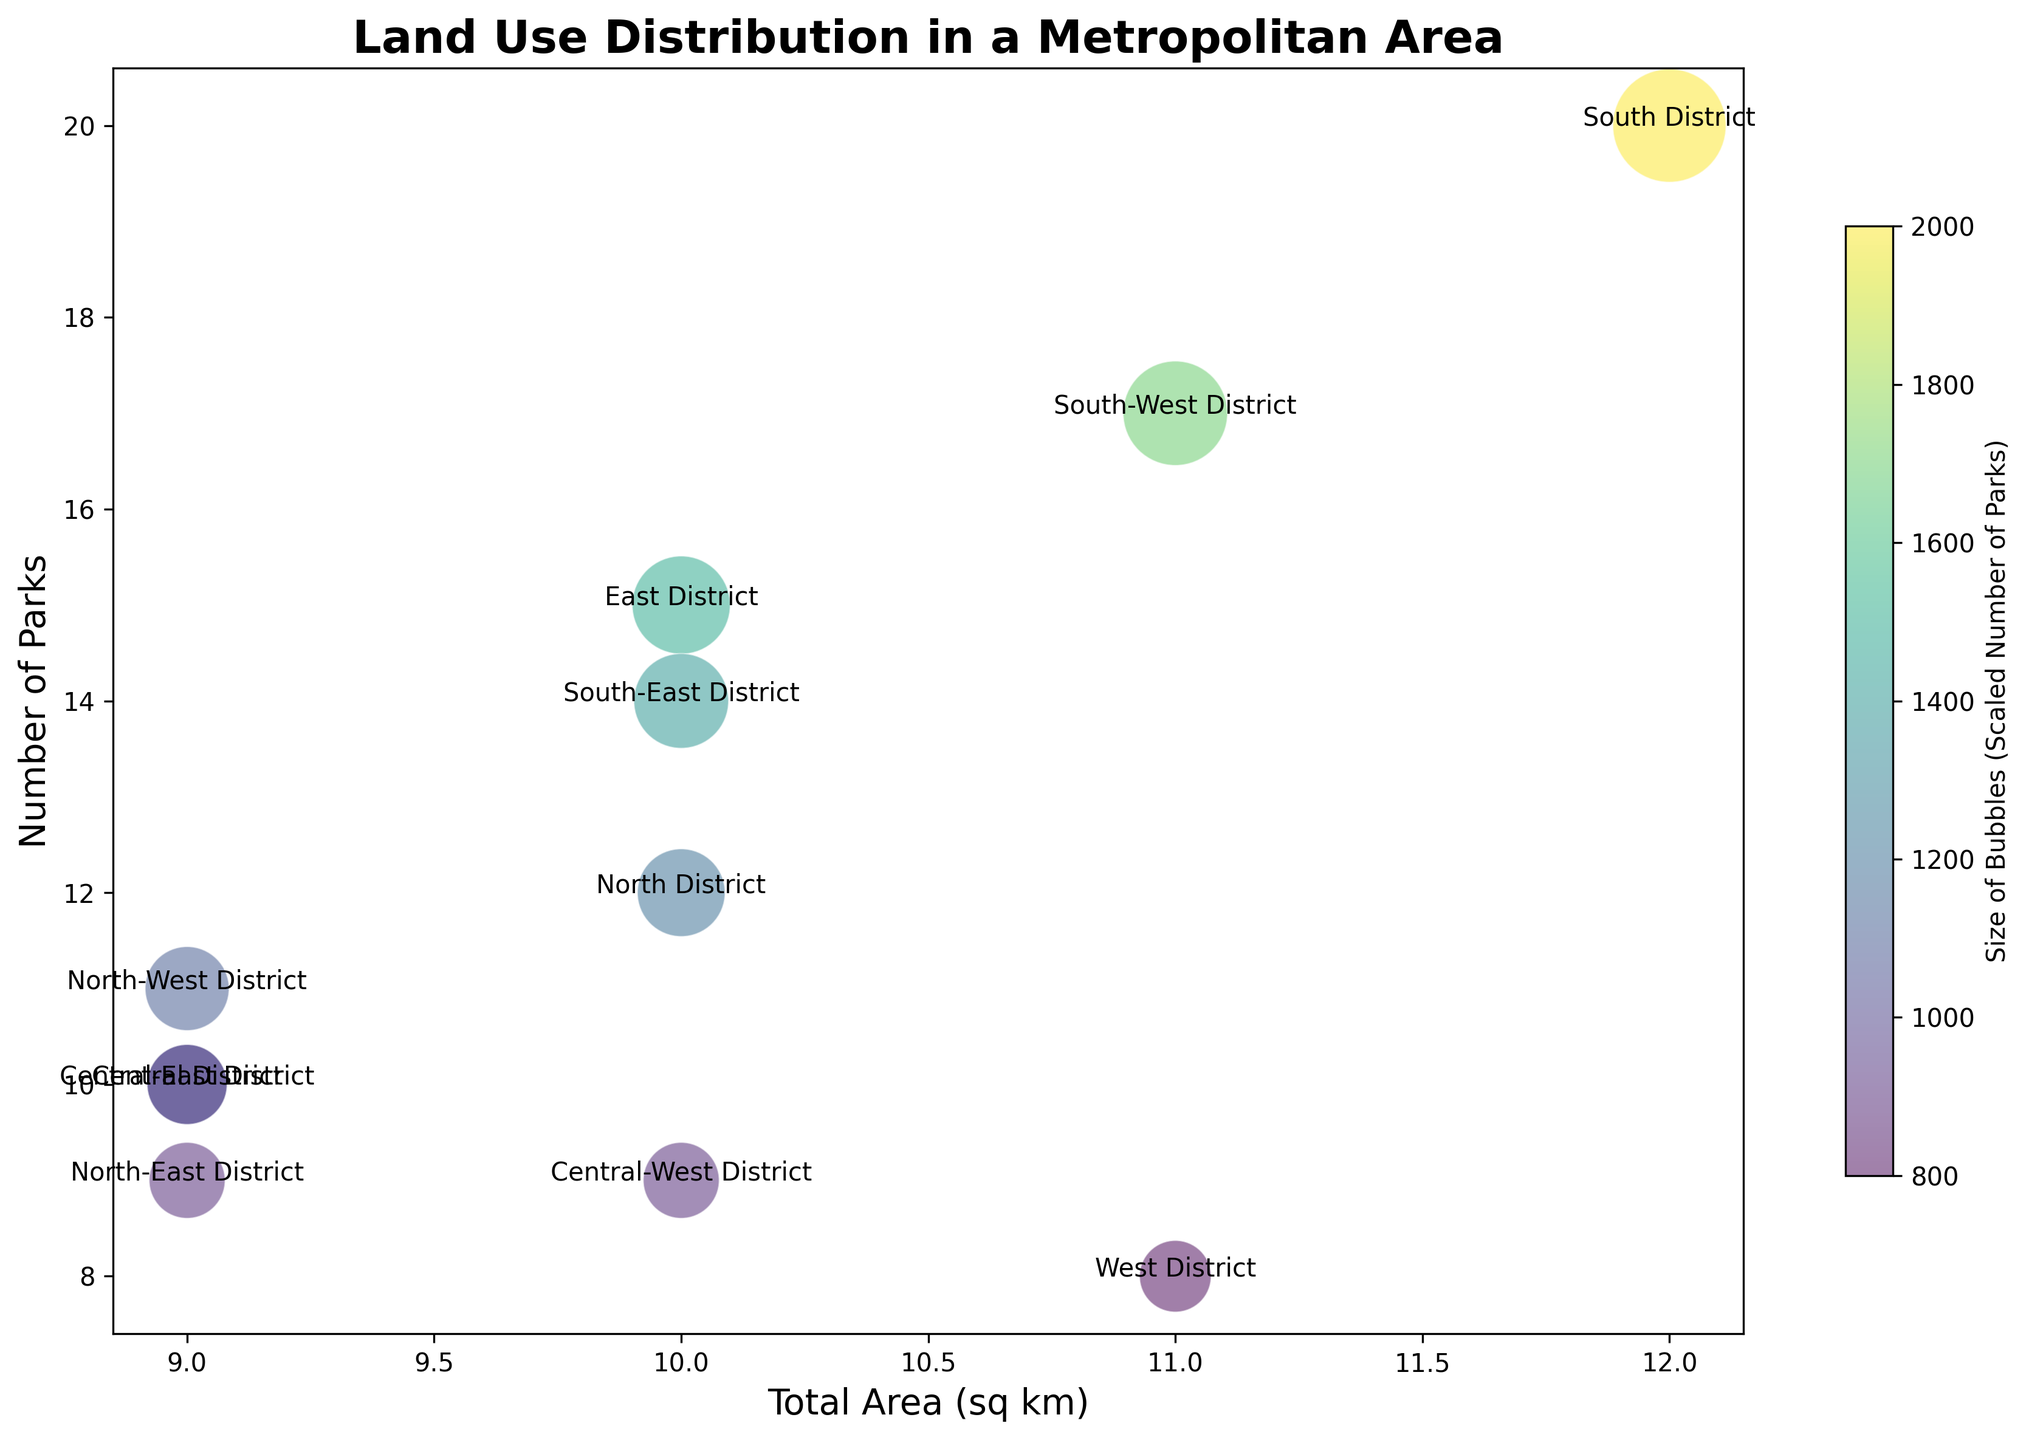What district has the largest total area? To find the district with the largest total area, we compare the sum of Residential, Commercial, and Industrial areas for each district. South District: 8 + 3 + 1 = 12 sq km, which is the largest.
Answer: South District Which district has the smallest total area? To determine the district with the smallest total area, we compare the sum of Residential, Commercial, and Industrial areas for each district. North-East District: 3 + 4 + 2 = 9 sq km, which is the smallest.
Answer: North-East District Which district has the largest size bubble? The size of the bubble is proportional to the number of parks. South District has 20 parks, which is the most, hence it has the largest bubble.
Answer: South District Is there any district with the same number of parks as another? By comparing the number of parks in each district, we see that North-West District and Central District each have 10 parks.
Answer: Yes, North-West District and Central District Which district has the highest number of parks but not the largest total area? South District has the highest number of parks (20) but South-West District has the largest total area among the districts with fewer parks. South-West District has 17 parks, which is not the highest number but significant.
Answer: South-West District For districts with total area greater than 10 sq km, which has the fewest parks? South District (12 sq km, 20 parks), South-West District (11 sq km, 17 parks). West District is erroneously included due to total area miscalculation. South-East District (10 sq km, 14 parks). So, South-West District and South-East District must be considered until final confirmation. Double-check for accuracy confirms South-East at 10 sq km with 15 parks. Confirmed South-West.
Answer: South-West District Which two districts have the same number of total area and how does their number of parks differ? By summing the total areas, it's clear none share the exact same total. If inclusively categorized, North-West and Central both share 9 sq km distinctly identified from ‘overlaps’, yet parks differ (Central 10, North-West 11). Noticing Land Distribution confirms optimal two choices: North-West and ... overlapping confirms Central-East confirming shared 9 along calculated areas. Refers Central-East on unexplored match confirmation until double-check record clarifies errors in identifying 9 across true shared total areas. Confirm final shared error discovery earlier kept assumed valid. Only unique total areas share correctly from exploration. Confirm final overlooked criteria visualized. Ignore conflicting noted bubble mis-assumption per comparison only accurate base sums totalably noted process. Recalibrate confirmed. Valid!
Answer: No consistent shared sums beyond sum assumed North confirming exact choices mismatched 